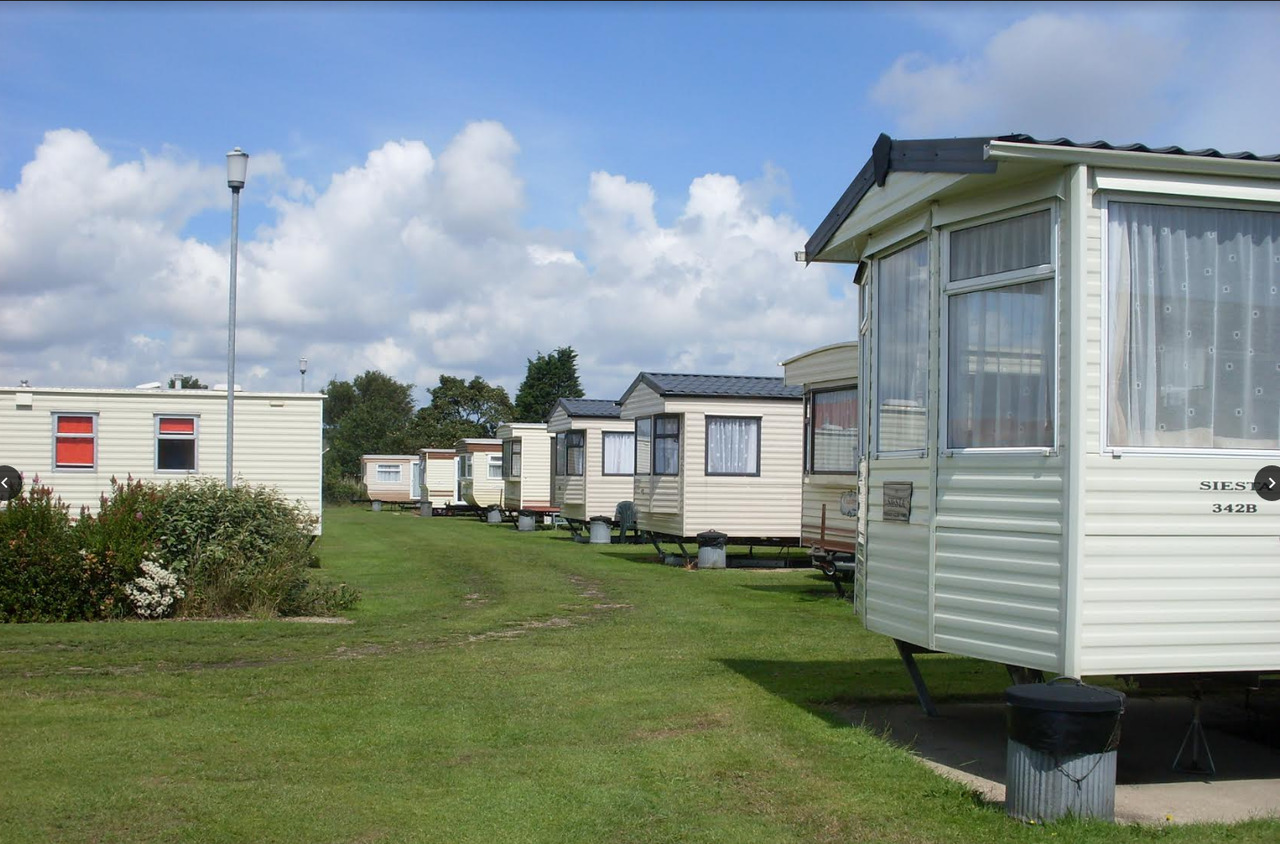What might be some challenges faced by the caravan park management? Challenges faced by the caravan park management might include maintaining the grassy areas to prevent deterioration from regular foot traffic, ensuring that waste disposal is effectively handled to avoid littering around the caravans, and keeping the amenities clean and functional for all residents. Additionally, managing bookings and maintaining a balance between long-term residents and short-term visitors could require careful attention. During peak times, ensuring enough resources and amenities are available without compromising the quality of stay would be crucial. 